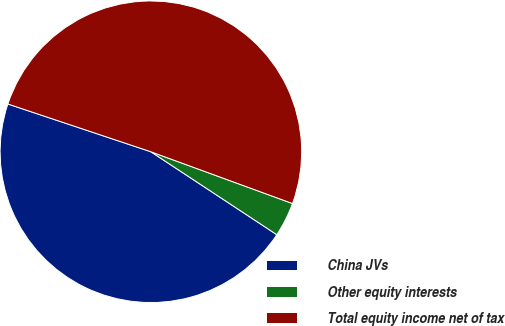<chart> <loc_0><loc_0><loc_500><loc_500><pie_chart><fcel>China JVs<fcel>Other equity interests<fcel>Total equity income net of tax<nl><fcel>45.86%<fcel>3.69%<fcel>50.45%<nl></chart> 